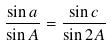<formula> <loc_0><loc_0><loc_500><loc_500>\frac { \sin a } { \sin A } = \frac { \sin c } { \sin 2 A }</formula> 